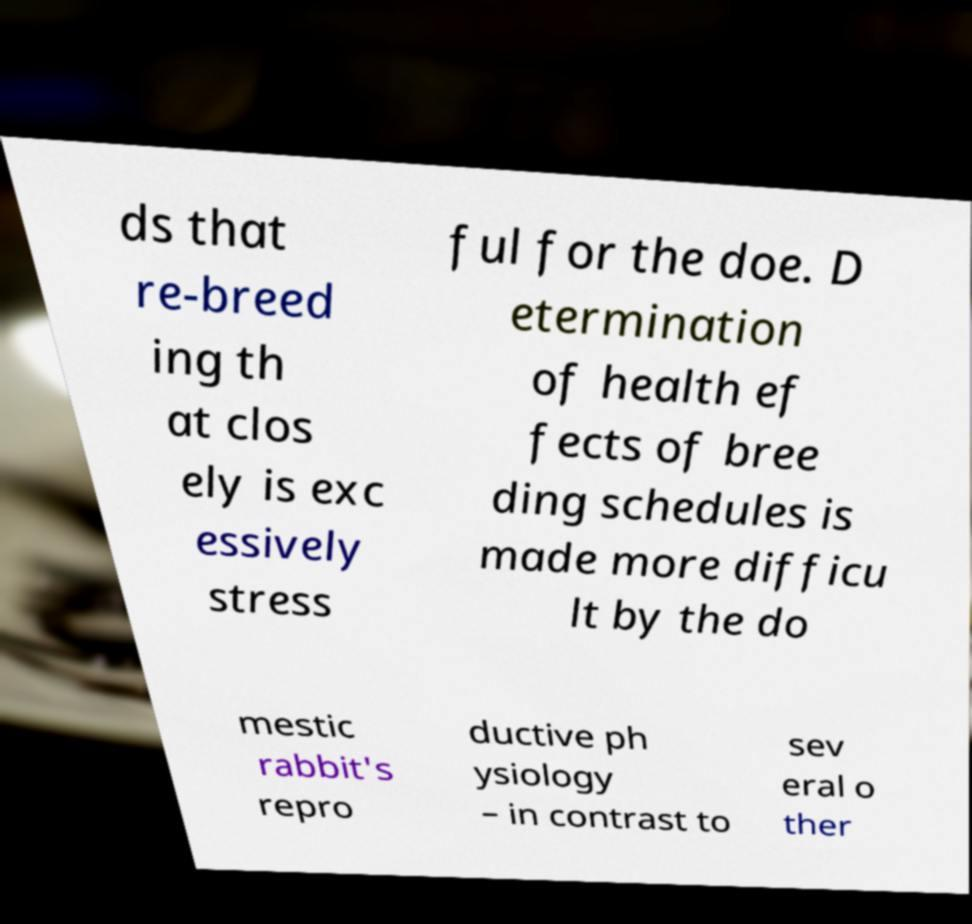For documentation purposes, I need the text within this image transcribed. Could you provide that? ds that re-breed ing th at clos ely is exc essively stress ful for the doe. D etermination of health ef fects of bree ding schedules is made more difficu lt by the do mestic rabbit's repro ductive ph ysiology – in contrast to sev eral o ther 